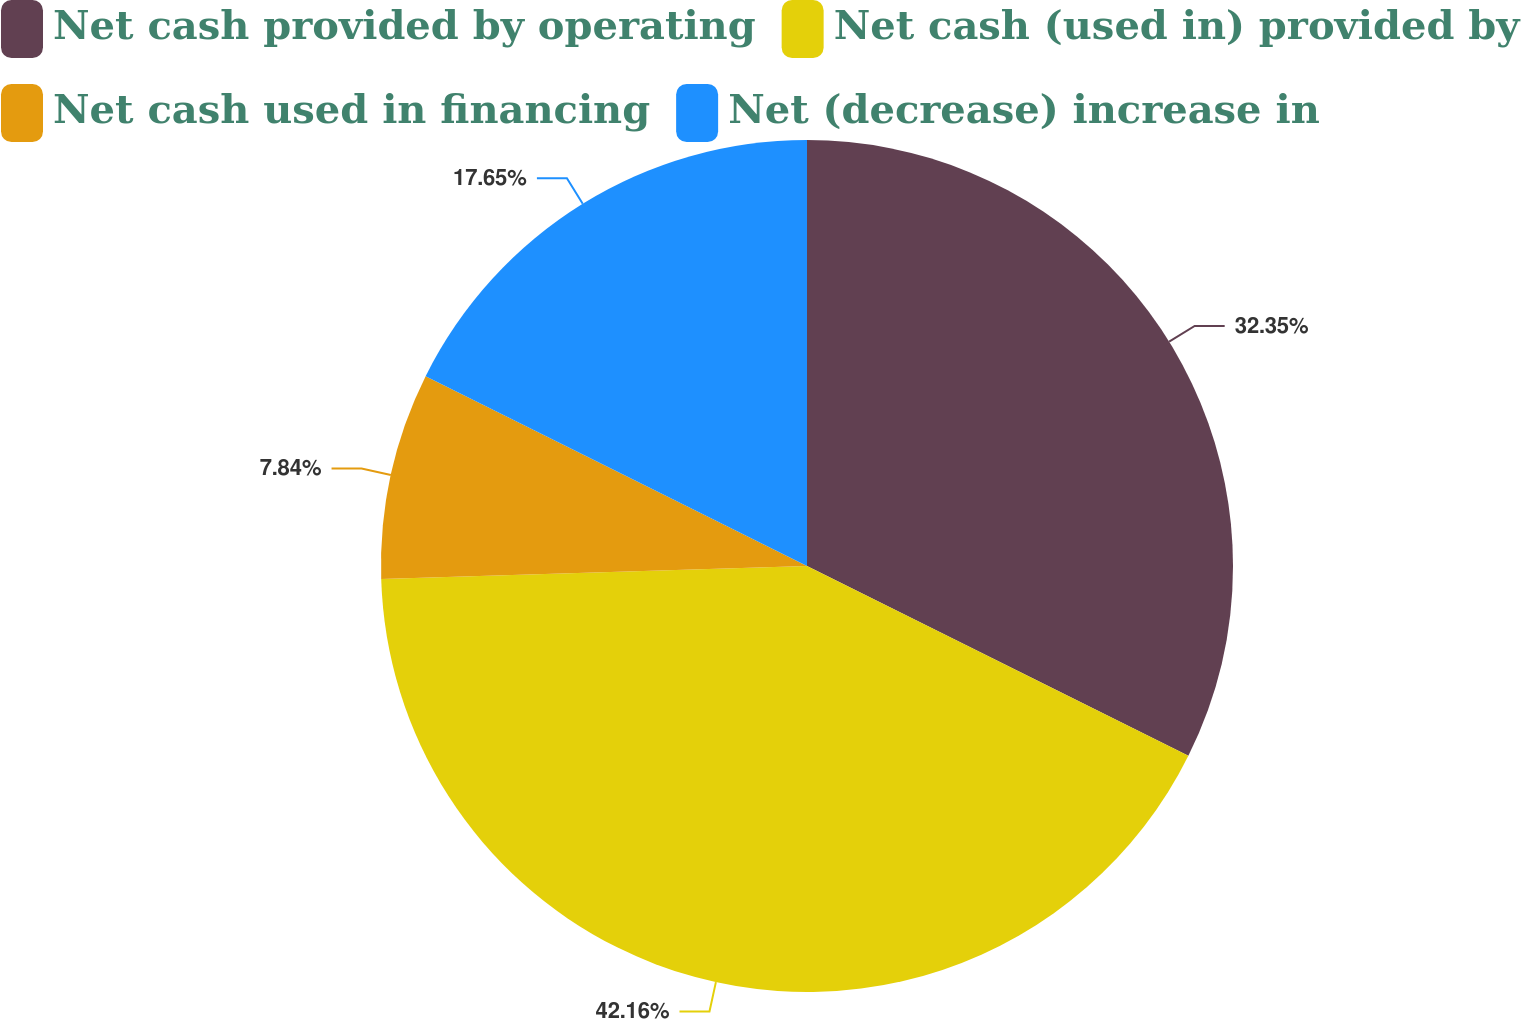Convert chart to OTSL. <chart><loc_0><loc_0><loc_500><loc_500><pie_chart><fcel>Net cash provided by operating<fcel>Net cash (used in) provided by<fcel>Net cash used in financing<fcel>Net (decrease) increase in<nl><fcel>32.35%<fcel>42.16%<fcel>7.84%<fcel>17.65%<nl></chart> 